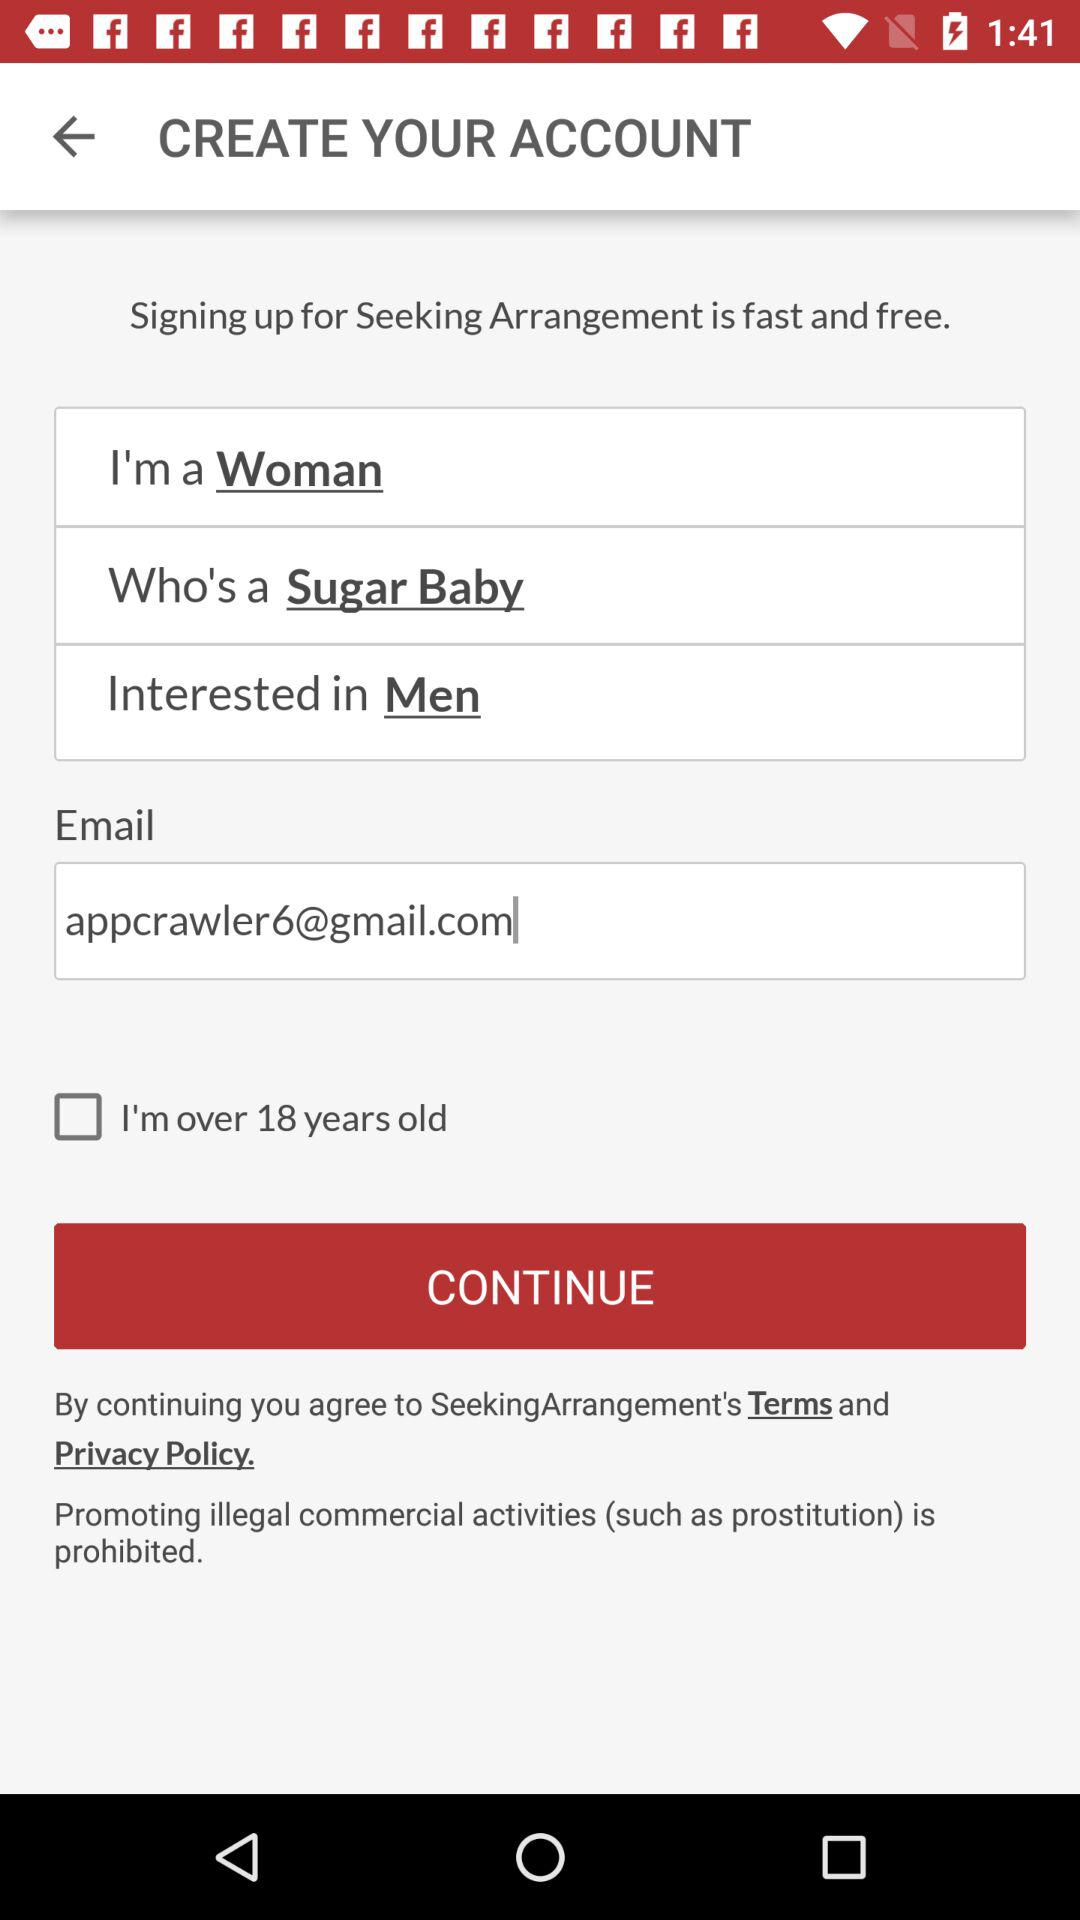What is the email ID of the user? The email ID of the user is appcrawler6@gmail.com. 